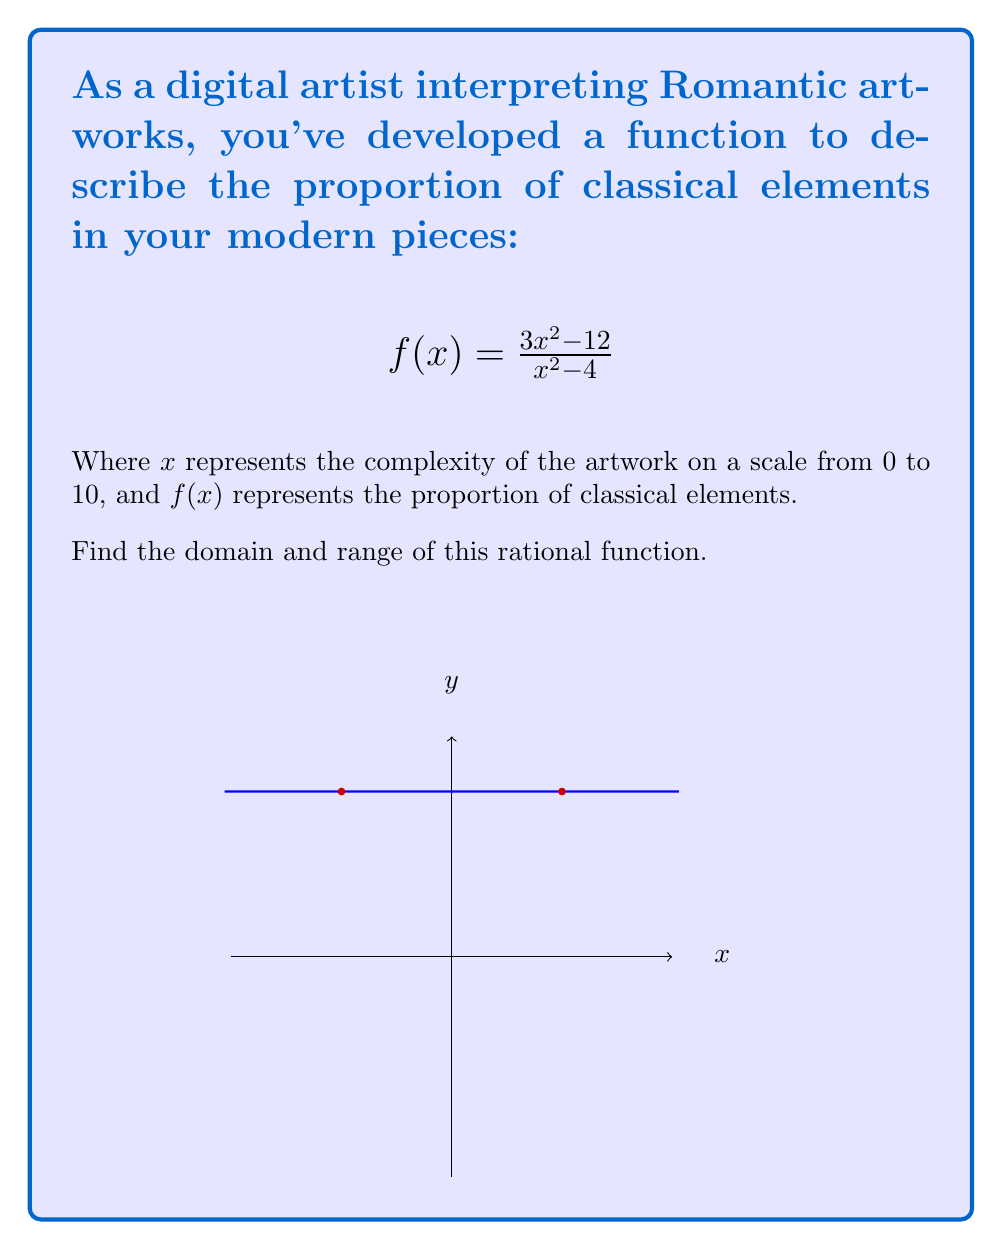Teach me how to tackle this problem. To find the domain and range of this rational function, we'll follow these steps:

1) Domain:
   The domain includes all real numbers except those that make the denominator zero.
   Set the denominator to zero and solve:
   $$x^2 - 4 = 0$$
   $$(x+2)(x-2) = 0$$
   $$x = \pm 2$$
   Therefore, the domain is all real numbers except 2 and -2.

2) Range:
   To find the range, let's analyze the function:
   
   a) As $x$ approaches infinity or negative infinity, the function approaches 3:
      $$\lim_{x \to \pm\infty} \frac{3x^2 - 12}{x^2 - 4} = 3$$

   b) Let's find the vertical asymptotes:
      At $x = \pm 2$, the function approaches positive and negative infinity.

   c) To find any horizontal asymptotes, we compare the degrees of the numerator and denominator:
      Both are quadratic, so the horizontal asymptote is the ratio of their leading coefficients: 3/1 = 3.

   d) To find any critical points, let's differentiate and set to zero:
      $$f'(x) = \frac{(x^2-4)(6x) - (3x^2-12)(2x)}{(x^2-4)^2} = \frac{24x}{(x^2-4)^2}$$
      This is zero when $x = 0$, giving us a critical point at (0, 3).

   Therefore, the function takes on all values except 3. The range is all real numbers except 3.
Answer: Domain: $x \in \mathbb{R}, x \neq \pm 2$; Range: $y \in \mathbb{R}, y \neq 3$ 